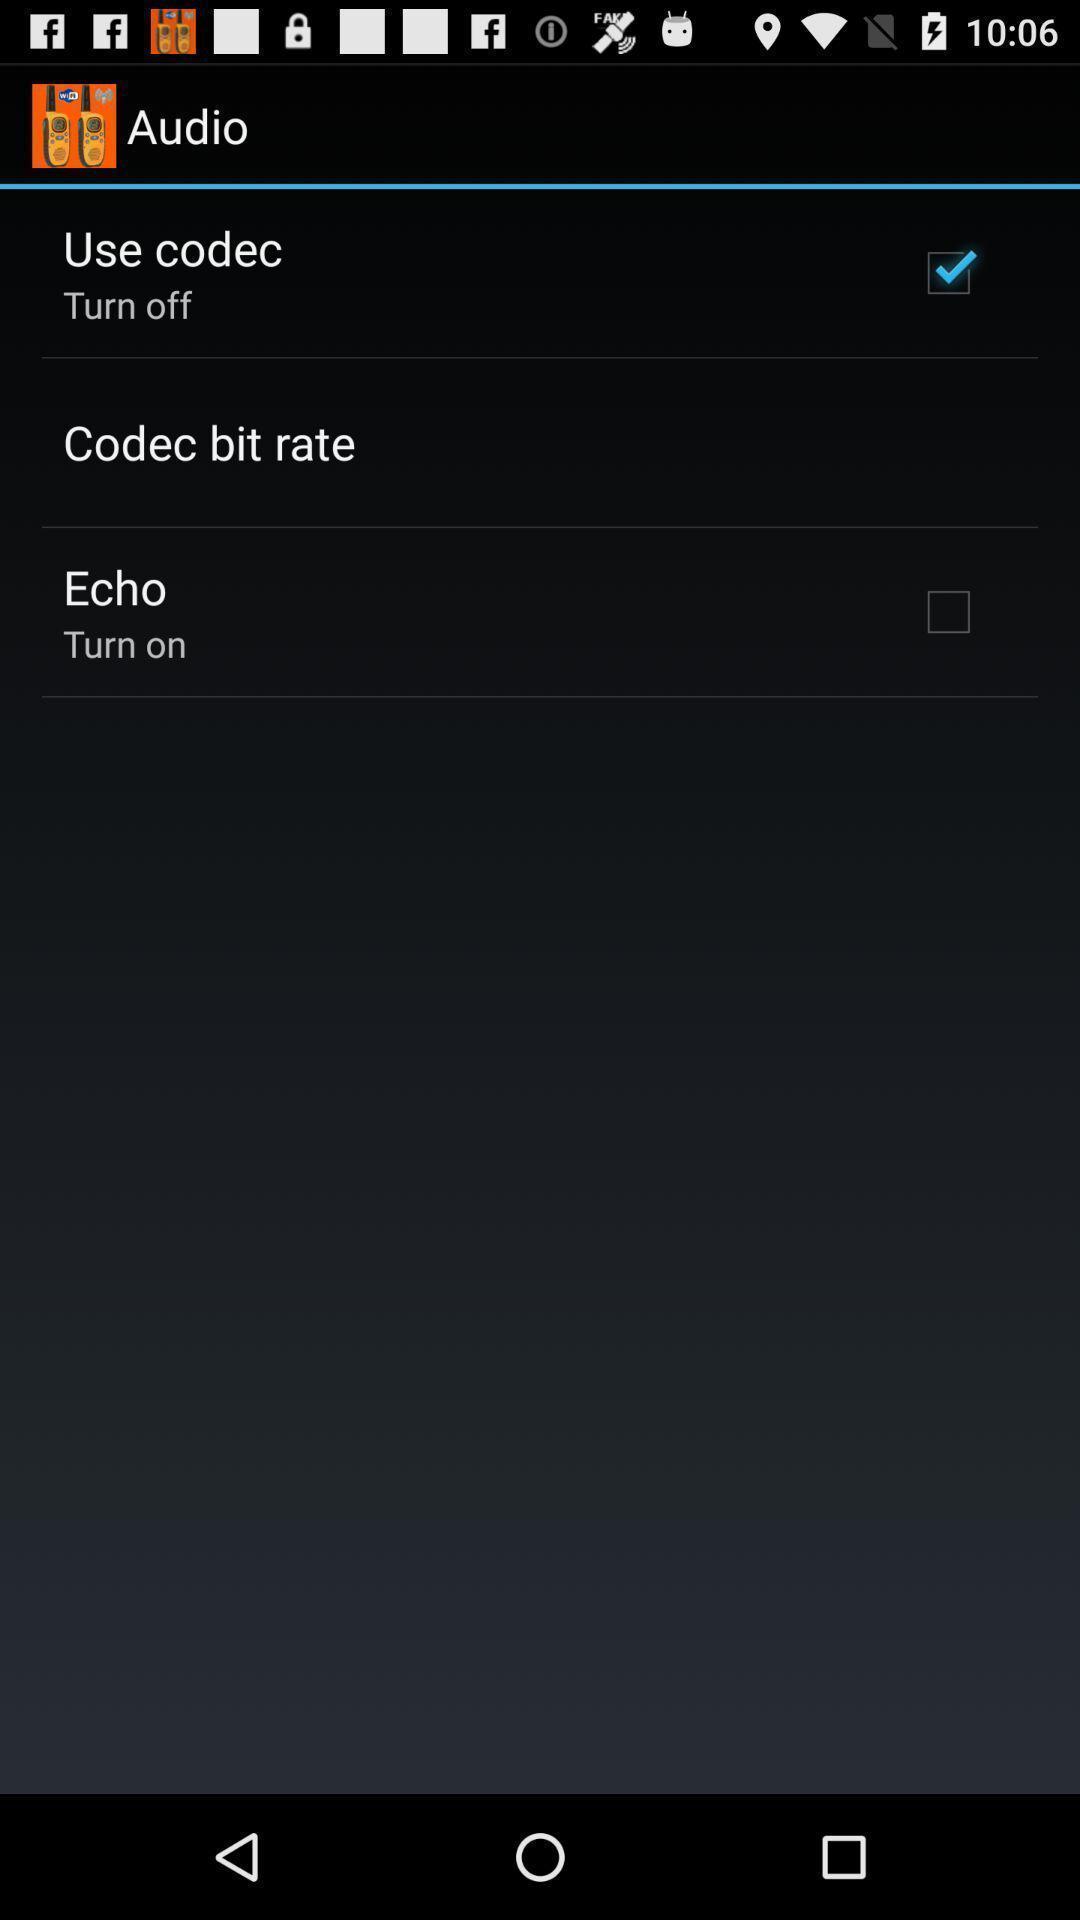Describe the visual elements of this screenshot. Screen shows audio with list. 